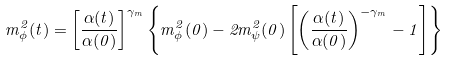<formula> <loc_0><loc_0><loc_500><loc_500>m _ { \phi } ^ { 2 } ( t ) = \left [ \frac { \alpha ( t ) } { \alpha ( 0 ) } \right ] ^ { \gamma _ { m } } \left \{ m ^ { 2 } _ { \phi } ( 0 ) - 2 m ^ { 2 } _ { \psi } ( 0 ) \left [ \left ( \frac { \alpha ( t ) } { \alpha ( 0 ) } \right ) ^ { - \gamma _ { m } } - 1 \right ] \right \}</formula> 